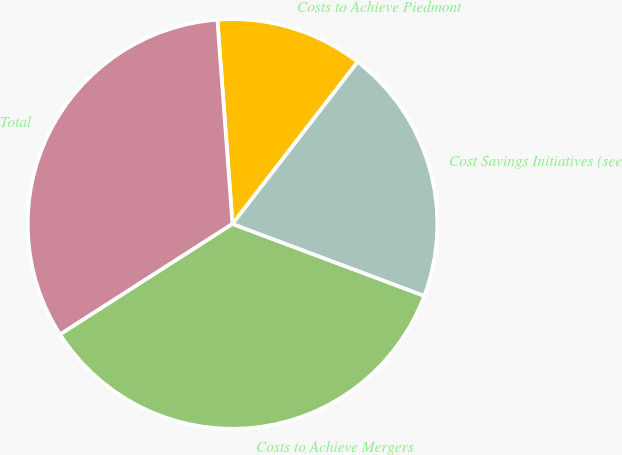<chart> <loc_0><loc_0><loc_500><loc_500><pie_chart><fcel>Costs to Achieve Piedmont<fcel>Total<fcel>Costs to Achieve Mergers<fcel>Cost Savings Initiatives (see<nl><fcel>11.64%<fcel>32.89%<fcel>35.22%<fcel>20.24%<nl></chart> 